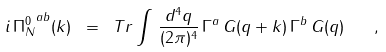Convert formula to latex. <formula><loc_0><loc_0><loc_500><loc_500>i \, { \Pi _ { N } ^ { 0 } } ^ { a b } ( k ) \ = \ T r \int \, \frac { d ^ { 4 } q } { ( 2 \pi ) ^ { 4 } } \, \Gamma ^ { a } \, G ( q + k ) \, \Gamma ^ { b } \, G ( q ) \quad ,</formula> 